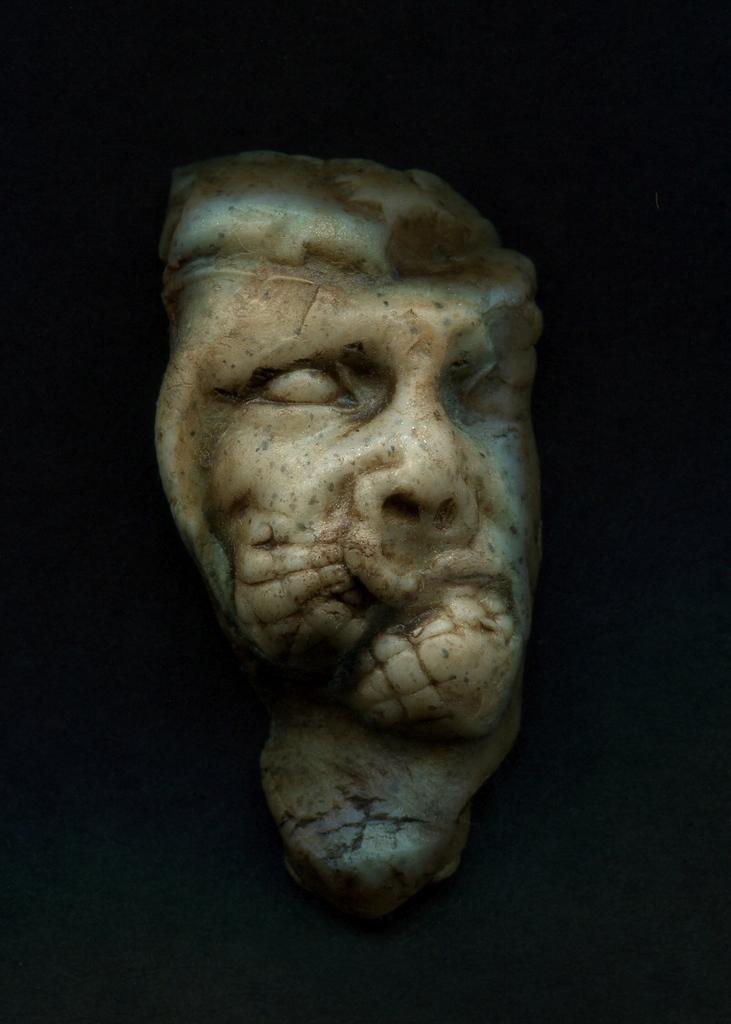Could you give a brief overview of what you see in this image? In this image in the center there is a sculpture, and in the background it looks like a wall. 